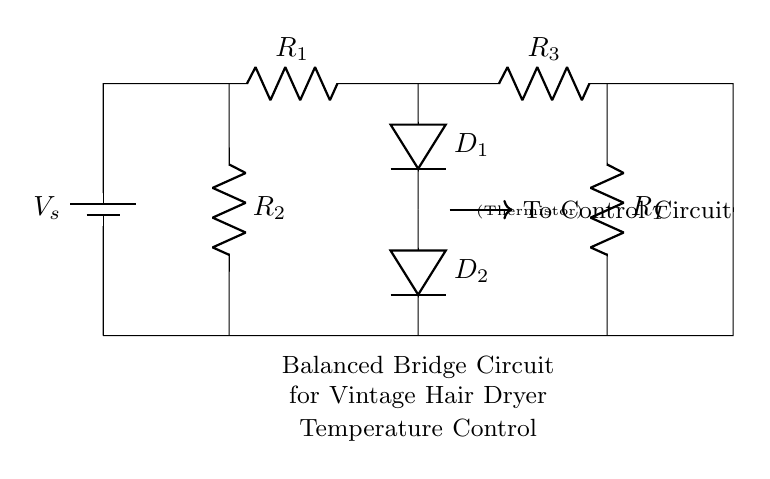What is the function of the thermistor? The thermistor is used to sense temperature changes. It responds to temperature variations, influencing the balance of the bridge circuit to control the heating element in the dryer.
Answer: Sensing temperature What components are connected to the top voltage source? The top voltage source is connected to resistors R1 and R3, as well as diodes D1 and D2, completing the upper part of the bridge circuit.
Answer: R1, R3, D1, D2 How many resistors are in the circuit? There are three resistors in the circuit: R1, R2, and R3, with R_T acting as the thermistor.
Answer: Three What is the role of the diodes in this circuit? The diodes D1 and D2 rectify the current, ensuring that the control circuit receives the appropriate signal for temperature regulation in one direction.
Answer: Rectification What happens when the resistance of the thermistor increases? When the thermistor's resistance increases, it creates an imbalance in the bridge, causing a change in voltage that signals the control circuit to adjust the heating element accordingly.
Answer: Signals adjustment What does the arrow in the diagram indicate? The arrow indicates the direction of the control signal flow from the bridge circuit to the control circuit, showing the feedback mechanism used for temperature regulation.
Answer: Control signal direction 